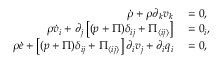<formula> <loc_0><loc_0><loc_500><loc_500>\begin{array} { r l } { \dot { \rho } + \rho \partial _ { k } v _ { k } } & = 0 , } \\ { \rho \dot { v } _ { i } + \partial _ { j } \left [ ( p + \Pi ) \delta _ { i j } + \Pi _ { \langle i j \rangle } \right ] } & = 0 _ { i } , } \\ { \rho \dot { e } + \left [ ( p + \Pi ) \delta _ { i j } + \Pi _ { \langle i j \rangle } \right ] \partial _ { i } v _ { j } + \partial _ { i } q _ { i } } & = 0 , } \end{array}</formula> 